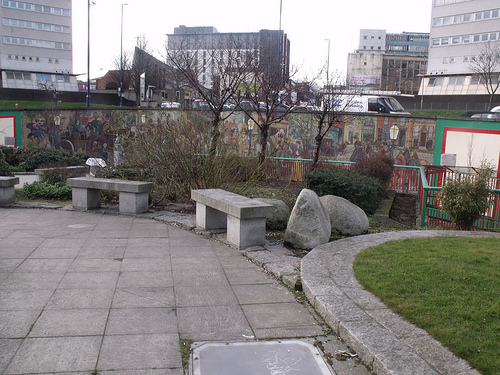<image>
Can you confirm if the rock is on the ledge? No. The rock is not positioned on the ledge. They may be near each other, but the rock is not supported by or resting on top of the ledge. Is the fence behind the bench? Yes. From this viewpoint, the fence is positioned behind the bench, with the bench partially or fully occluding the fence. 